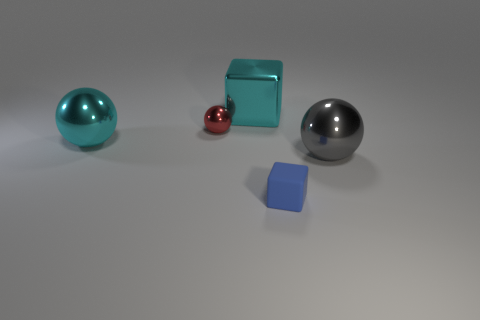Add 3 large metal blocks. How many objects exist? 8 Subtract all gray things. Subtract all yellow metal cylinders. How many objects are left? 4 Add 5 cyan cubes. How many cyan cubes are left? 6 Add 3 large gray objects. How many large gray objects exist? 4 Subtract all blue cubes. How many cubes are left? 1 Subtract all small balls. How many balls are left? 2 Subtract 0 gray cylinders. How many objects are left? 5 Subtract all cubes. How many objects are left? 3 Subtract 1 blocks. How many blocks are left? 1 Subtract all green spheres. Subtract all brown cylinders. How many spheres are left? 3 